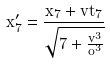Convert formula to latex. <formula><loc_0><loc_0><loc_500><loc_500>x _ { 7 } ^ { \prime } = \frac { x _ { 7 } + v t _ { 7 } } { \sqrt { 7 + \frac { v ^ { 3 } } { o ^ { 3 } } } }</formula> 